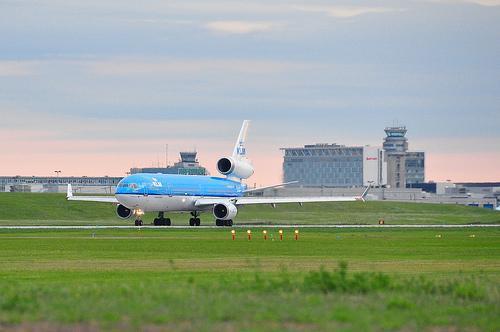How many orange cones are there?
Give a very brief answer. 1. How many lights are clustered near the runway?
Give a very brief answer. 5. How many planes are in the picture?
Give a very brief answer. 1. 